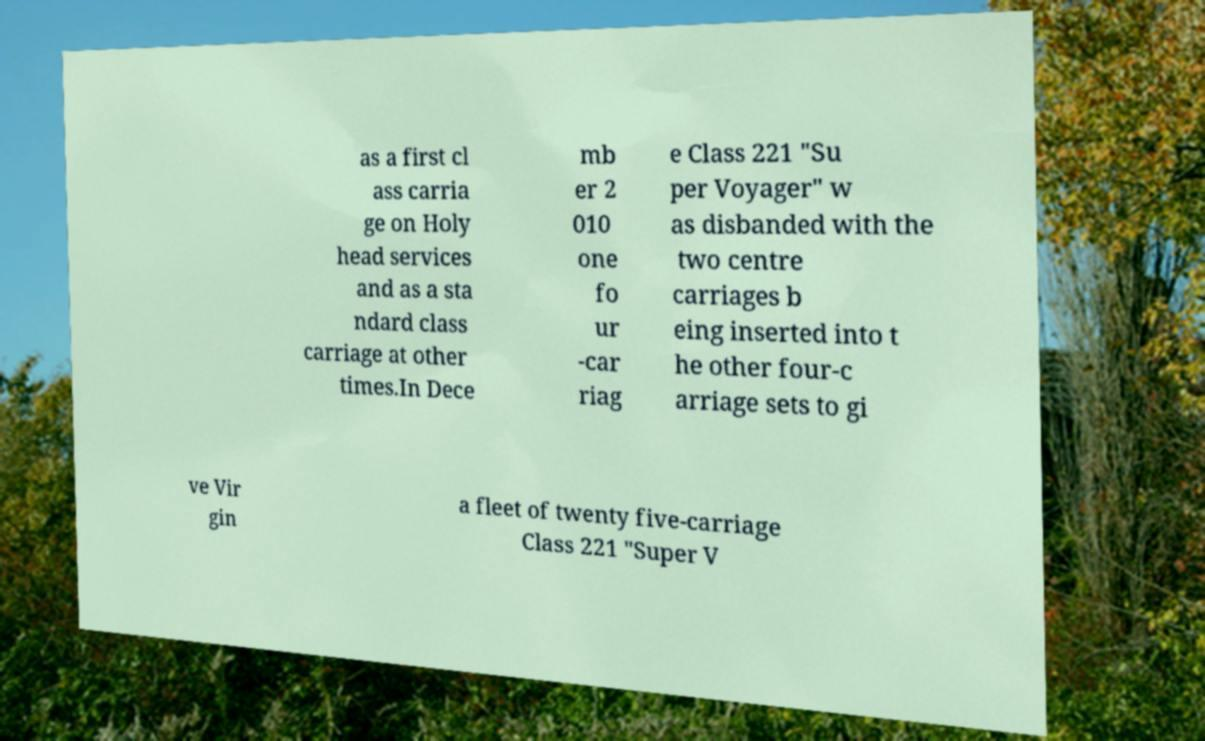Can you accurately transcribe the text from the provided image for me? as a first cl ass carria ge on Holy head services and as a sta ndard class carriage at other times.In Dece mb er 2 010 one fo ur -car riag e Class 221 "Su per Voyager" w as disbanded with the two centre carriages b eing inserted into t he other four-c arriage sets to gi ve Vir gin a fleet of twenty five-carriage Class 221 "Super V 